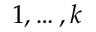Convert formula to latex. <formula><loc_0><loc_0><loc_500><loc_500>1 , \dots , k</formula> 